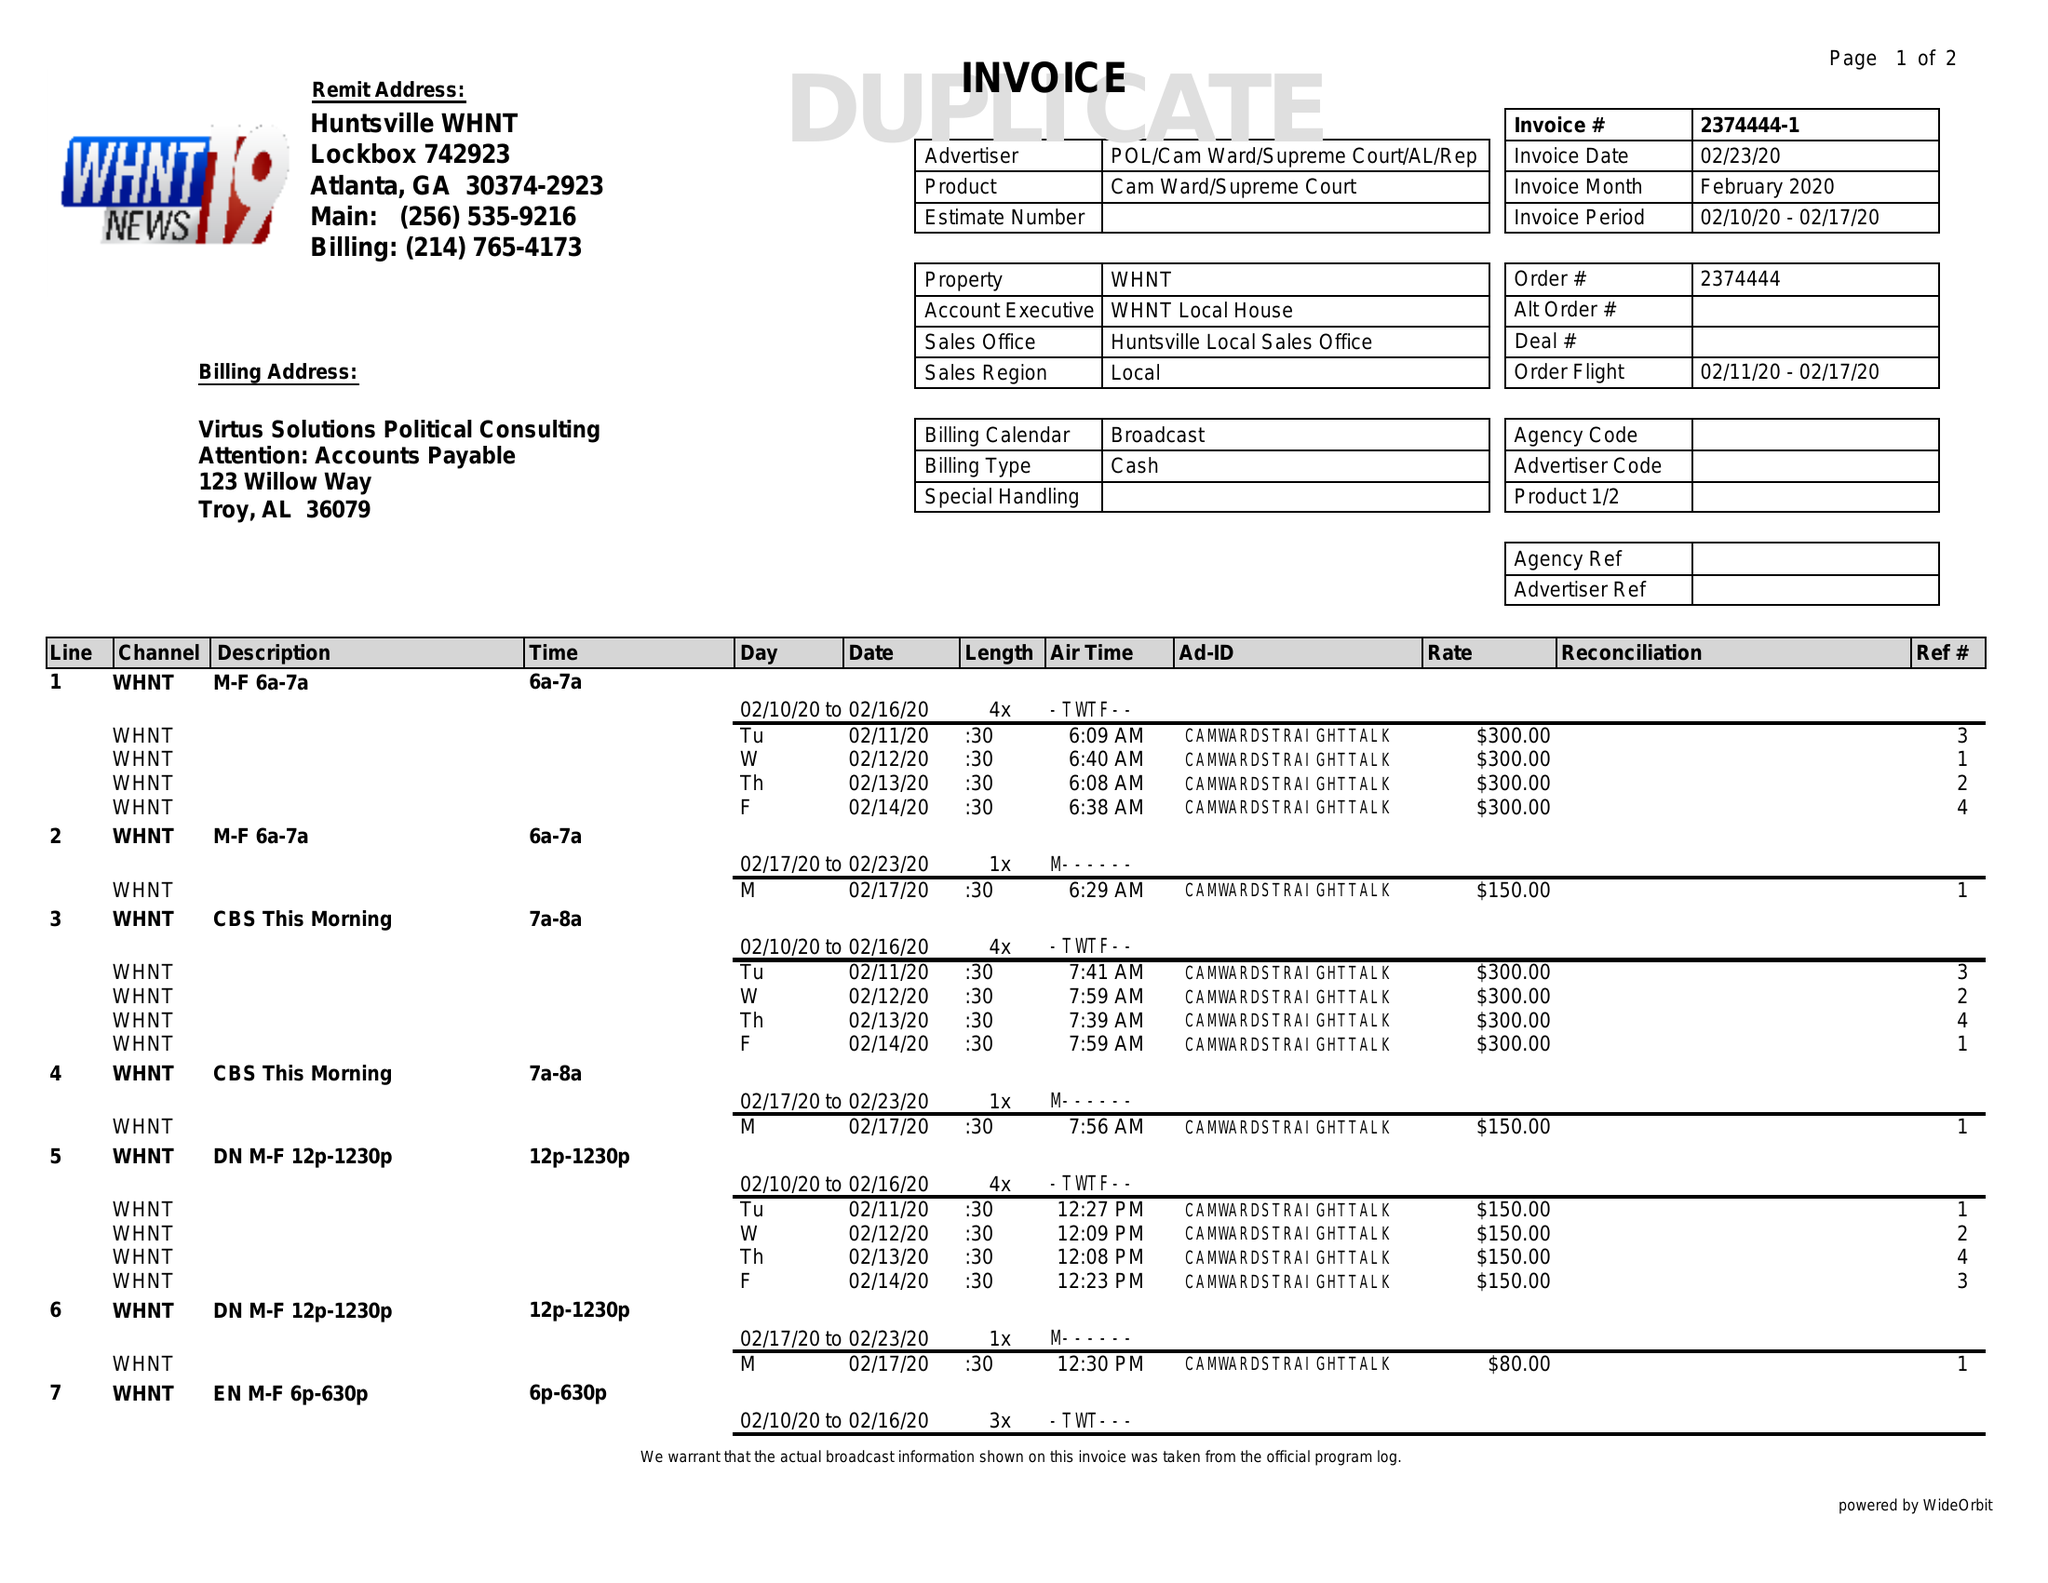What is the value for the flight_from?
Answer the question using a single word or phrase. 02/11/20 